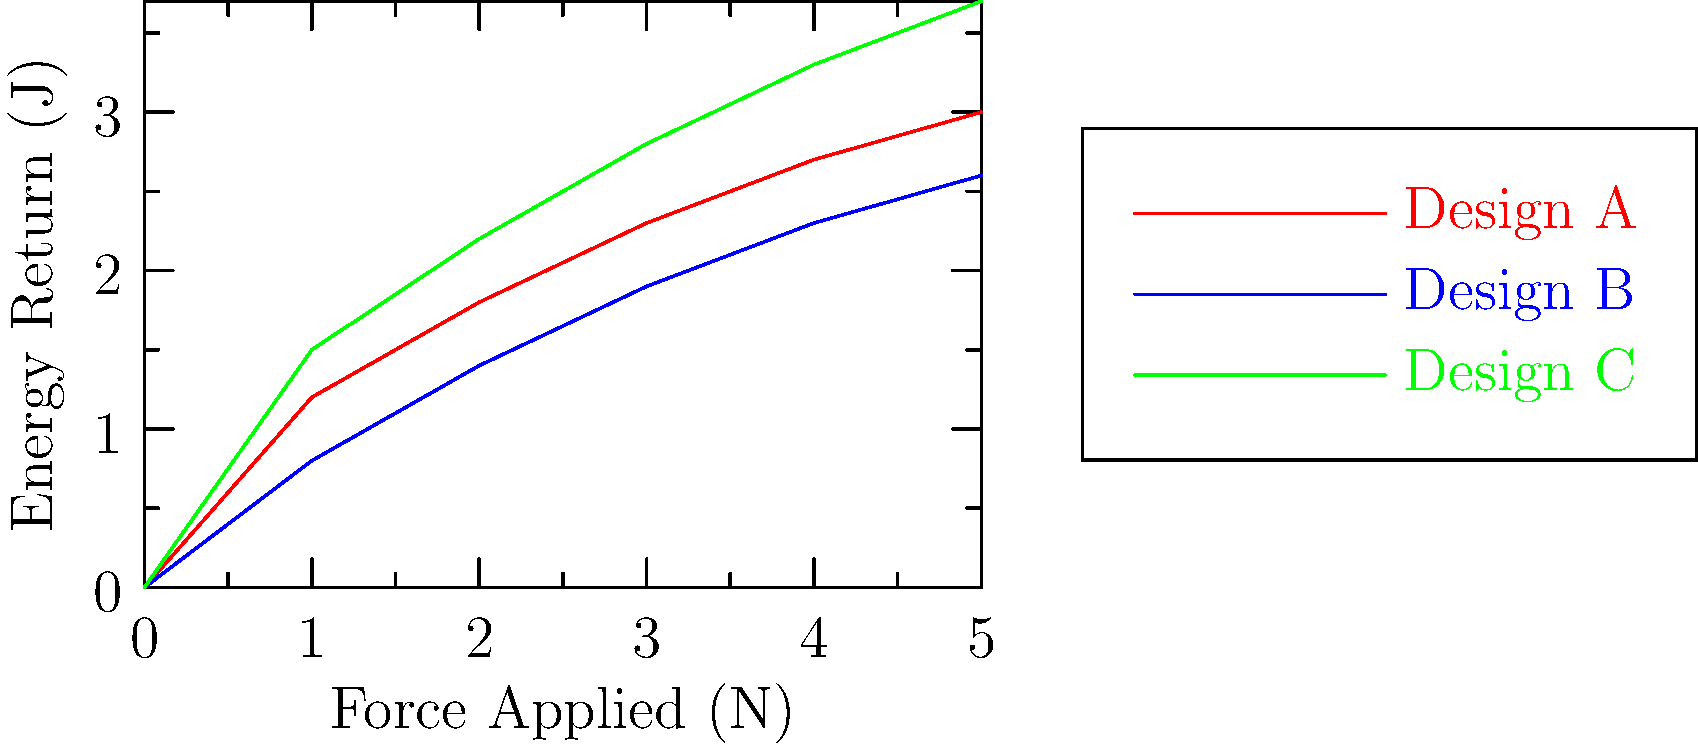Based on the energy return comparison graphs for three different running shoe designs, which design would likely be most beneficial for long-distance runners in terms of energy efficiency? How might this data influence policy decisions regarding athletic equipment standards? To answer this question, we need to analyze the graph and consider the implications for both runners and policy decisions:

1. Interpret the graph:
   - The x-axis represents the force applied (in Newtons)
   - The y-axis represents the energy return (in Joules)
   - Three shoe designs (A, B, and C) are compared

2. Analyze energy return:
   - Design C (green) shows the highest energy return across all force levels
   - Design A (red) has the second-highest energy return
   - Design B (blue) has the lowest energy return

3. Consider long-distance running implications:
   - Higher energy return means more efficient energy use during running
   - More efficient energy use can lead to less fatigue over long distances
   - Design C would likely be most beneficial for long-distance runners

4. Policy implications:
   - This data could inform standards for athletic equipment performance
   - Policymakers might consider:
     a) Setting minimum energy return standards for running shoes
     b) Requiring manufacturers to disclose energy return data
     c) Balancing innovation incentives with fair competition concerns

5. Balancing interests:
   - Consumer interest: access to high-performance, energy-efficient shoes
   - Corporate interest: protecting proprietary designs and technologies
   - Policy challenge: encouraging innovation while ensuring fair market practices

6. Potential policy approaches:
   - Implement a tiered classification system for running shoes based on energy return
   - Require clear labeling of energy return performance for consumer information
   - Establish guidelines for energy return claims in marketing materials

By analyzing this data, policymakers can work towards regulations that promote transparency, innovation, and consumer benefits in the athletic footwear industry.
Answer: Design C; inform equipment standards, balance innovation and fair competition 